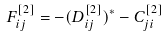<formula> <loc_0><loc_0><loc_500><loc_500>F ^ { [ 2 ] } _ { i j } = - ( D ^ { [ 2 ] } _ { i j } ) ^ { \ast } - C ^ { [ 2 ] } _ { j i }</formula> 